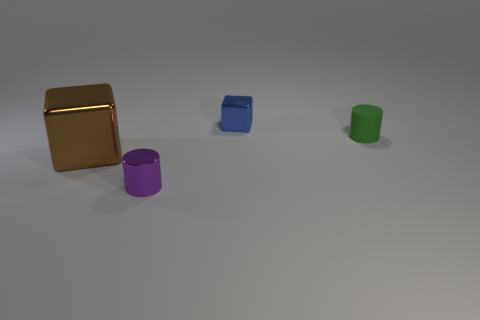Is there anything else that has the same material as the tiny green object?
Your response must be concise. No. Is the shape of the purple object the same as the big object?
Make the answer very short. No. Is the thing behind the small rubber cylinder made of the same material as the cylinder that is in front of the matte thing?
Provide a short and direct response. Yes. How many objects are either metal cubes that are to the left of the small metallic cylinder or objects to the left of the tiny purple cylinder?
Offer a terse response. 1. Is there anything else that has the same shape as the small purple metal thing?
Provide a succinct answer. Yes. What number of purple cylinders are there?
Ensure brevity in your answer.  1. Is there a green cylinder that has the same size as the blue block?
Give a very brief answer. Yes. Is the material of the purple object the same as the block left of the blue shiny cube?
Make the answer very short. Yes. There is a cylinder that is on the right side of the purple cylinder; what material is it?
Your response must be concise. Rubber. The matte cylinder is what size?
Your answer should be compact. Small. 